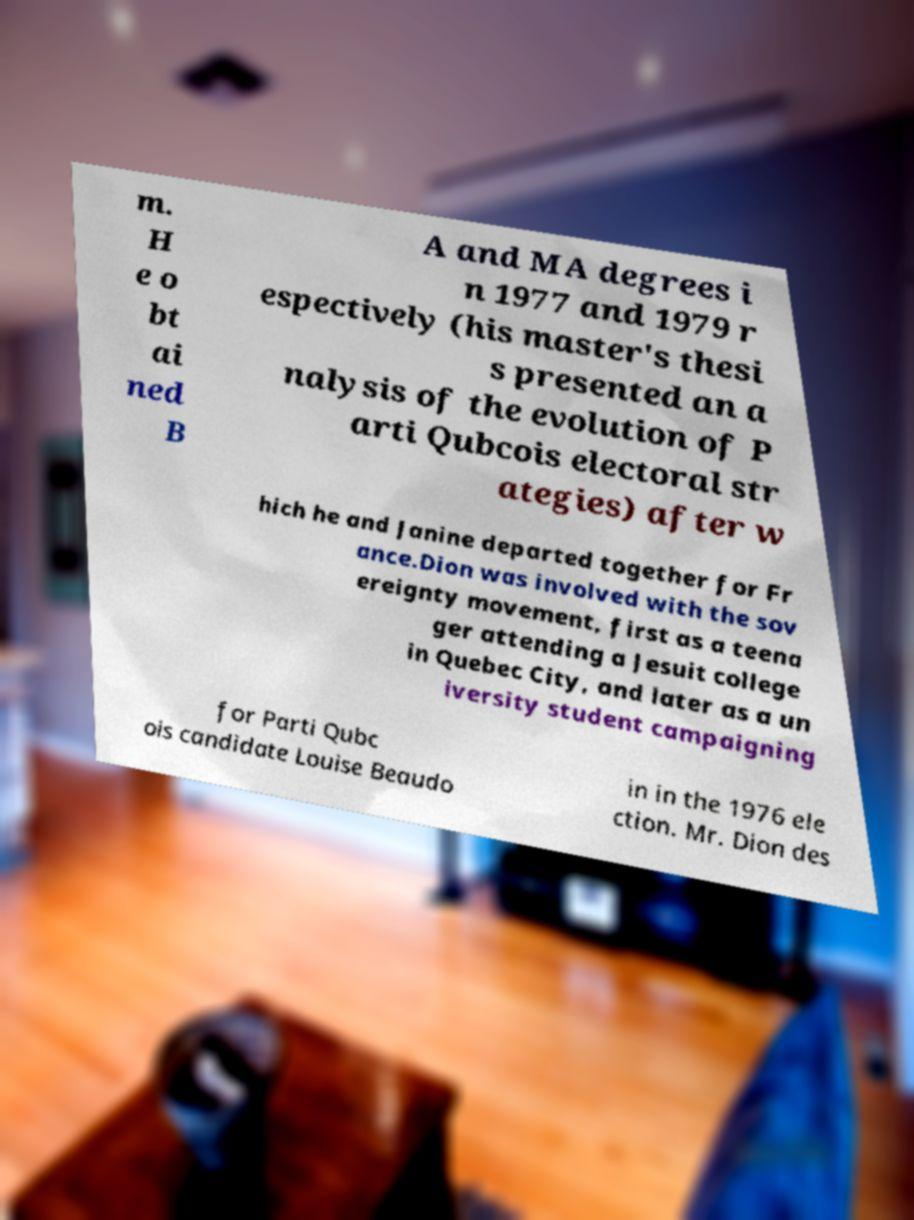What messages or text are displayed in this image? I need them in a readable, typed format. m. H e o bt ai ned B A and MA degrees i n 1977 and 1979 r espectively (his master's thesi s presented an a nalysis of the evolution of P arti Qubcois electoral str ategies) after w hich he and Janine departed together for Fr ance.Dion was involved with the sov ereignty movement, first as a teena ger attending a Jesuit college in Quebec City, and later as a un iversity student campaigning for Parti Qubc ois candidate Louise Beaudo in in the 1976 ele ction. Mr. Dion des 